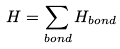Convert formula to latex. <formula><loc_0><loc_0><loc_500><loc_500>H = \sum _ { b o n d } H _ { b o n d }</formula> 